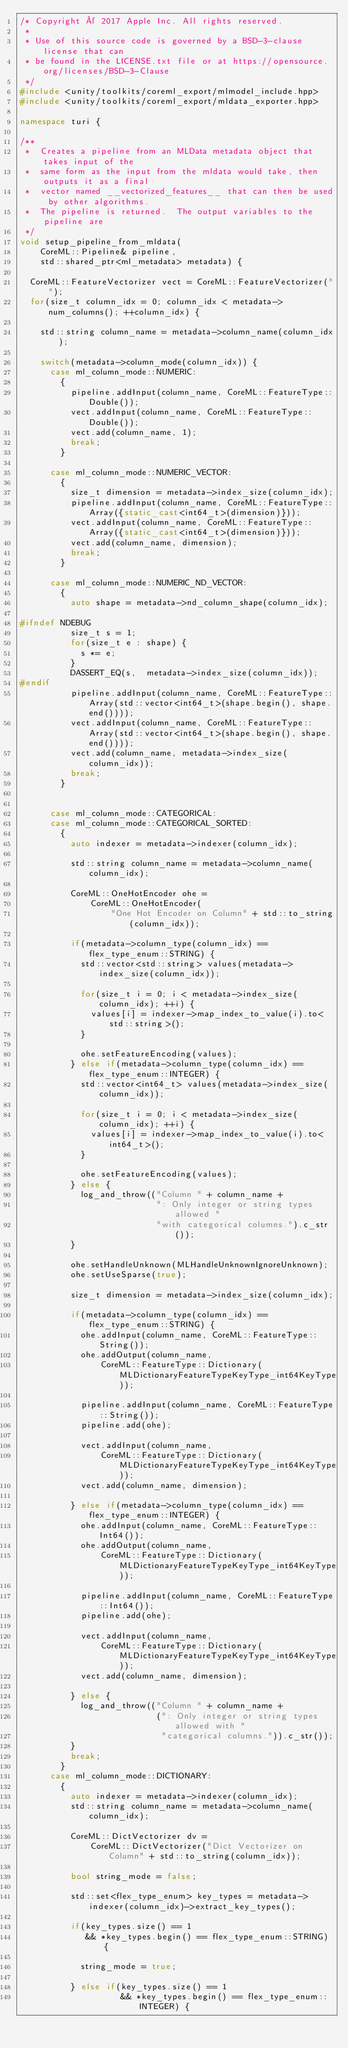Convert code to text. <code><loc_0><loc_0><loc_500><loc_500><_C++_>/* Copyright © 2017 Apple Inc. All rights reserved.
 *
 * Use of this source code is governed by a BSD-3-clause license that can
 * be found in the LICENSE.txt file or at https://opensource.org/licenses/BSD-3-Clause
 */
#include <unity/toolkits/coreml_export/mlmodel_include.hpp> 
#include <unity/toolkits/coreml_export/mldata_exporter.hpp>

namespace turi { 

/**
 *  Creates a pipeline from an MLData metadata object that takes input of the 
 *  same form as the input from the mldata would take, then outputs it as a final 
 *  vector named __vectorized_features__ that can then be used by other algorithms.
 *  The pipeline is returned.  The output variables to the pipeline are 
 */
void setup_pipeline_from_mldata(
    CoreML::Pipeline& pipeline,
    std::shared_ptr<ml_metadata> metadata) {

  CoreML::FeatureVectorizer vect = CoreML::FeatureVectorizer("");
  for(size_t column_idx = 0; column_idx < metadata->num_columns(); ++column_idx) {

    std::string column_name = metadata->column_name(column_idx);

    switch(metadata->column_mode(column_idx)) {
      case ml_column_mode::NUMERIC:
        {
          pipeline.addInput(column_name, CoreML::FeatureType::Double());
          vect.addInput(column_name, CoreML::FeatureType::Double());
          vect.add(column_name, 1);
          break;
        }

      case ml_column_mode::NUMERIC_VECTOR:
        {
          size_t dimension = metadata->index_size(column_idx);
          pipeline.addInput(column_name, CoreML::FeatureType::Array({static_cast<int64_t>(dimension)}));
          vect.addInput(column_name, CoreML::FeatureType::Array({static_cast<int64_t>(dimension)}));
          vect.add(column_name, dimension);
          break;
        }

      case ml_column_mode::NUMERIC_ND_VECTOR:
        {
          auto shape = metadata->nd_column_shape(column_idx);

#ifndef NDEBUG
          size_t s = 1;
          for(size_t e : shape) {
            s *= e;
          }
          DASSERT_EQ(s,  metadata->index_size(column_idx));
#endif
          pipeline.addInput(column_name, CoreML::FeatureType::Array(std::vector<int64_t>(shape.begin(), shape.end())));
          vect.addInput(column_name, CoreML::FeatureType::Array(std::vector<int64_t>(shape.begin(), shape.end())));
          vect.add(column_name, metadata->index_size(column_idx));
          break;
        }


      case ml_column_mode::CATEGORICAL:
      case ml_column_mode::CATEGORICAL_SORTED:
        {
          auto indexer = metadata->indexer(column_idx);

          std::string column_name = metadata->column_name(column_idx);

          CoreML::OneHotEncoder ohe =
              CoreML::OneHotEncoder(
                  "One Hot Encoder on Column" + std::to_string(column_idx));

          if(metadata->column_type(column_idx) == flex_type_enum::STRING) {
            std::vector<std::string> values(metadata->index_size(column_idx));

            for(size_t i = 0; i < metadata->index_size(column_idx); ++i) {
              values[i] = indexer->map_index_to_value(i).to<std::string>();
            }

            ohe.setFeatureEncoding(values);
          } else if(metadata->column_type(column_idx) == flex_type_enum::INTEGER) {
            std::vector<int64_t> values(metadata->index_size(column_idx));

            for(size_t i = 0; i < metadata->index_size(column_idx); ++i) {
              values[i] = indexer->map_index_to_value(i).to<int64_t>();
            }

            ohe.setFeatureEncoding(values);
          } else {
            log_and_throw(("Column " + column_name +
                           ": Only integer or string types allowed "
                           "with categorical columns.").c_str());
          }

          ohe.setHandleUnknown(MLHandleUnknownIgnoreUnknown);
          ohe.setUseSparse(true);

          size_t dimension = metadata->index_size(column_idx);

          if(metadata->column_type(column_idx) == flex_type_enum::STRING) {
            ohe.addInput(column_name, CoreML::FeatureType::String());
            ohe.addOutput(column_name, 
                CoreML::FeatureType::Dictionary(MLDictionaryFeatureTypeKeyType_int64KeyType));

            pipeline.addInput(column_name, CoreML::FeatureType::String());
            pipeline.add(ohe);

            vect.addInput(column_name, 
                CoreML::FeatureType::Dictionary(MLDictionaryFeatureTypeKeyType_int64KeyType));
            vect.add(column_name, dimension);

          } else if(metadata->column_type(column_idx) == flex_type_enum::INTEGER) {
            ohe.addInput(column_name, CoreML::FeatureType::Int64());
            ohe.addOutput(column_name,
                CoreML::FeatureType::Dictionary(MLDictionaryFeatureTypeKeyType_int64KeyType));

            pipeline.addInput(column_name, CoreML::FeatureType::Int64());
            pipeline.add(ohe);

            vect.addInput(column_name, 
                CoreML::FeatureType::Dictionary(MLDictionaryFeatureTypeKeyType_int64KeyType));
            vect.add(column_name, dimension);

          } else {
            log_and_throw(("Column " + column_name +
                           (": Only integer or string types allowed with "
                            "categorical columns.")).c_str());
          }
          break;
        }
      case ml_column_mode::DICTIONARY:
        {
          auto indexer = metadata->indexer(column_idx);
          std::string column_name = metadata->column_name(column_idx);

          CoreML::DictVectorizer dv =
              CoreML::DictVectorizer("Dict Vectorizer on Column" + std::to_string(column_idx));

          bool string_mode = false; 

          std::set<flex_type_enum> key_types = metadata->indexer(column_idx)->extract_key_types(); 

          if(key_types.size() == 1 
             && *key_types.begin() == flex_type_enum::STRING) { 

            string_mode = true;
          
          } else if(key_types.size() == 1 
                    && *key_types.begin() == flex_type_enum::INTEGER) {
</code> 